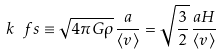Convert formula to latex. <formula><loc_0><loc_0><loc_500><loc_500>k _ { \ } f s \equiv \sqrt { 4 \pi G \rho } \, \frac { a } { \langle v \rangle } = \sqrt { \frac { 3 } { 2 } } \, \frac { a H } { \langle v \rangle }</formula> 